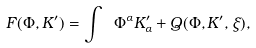<formula> <loc_0><loc_0><loc_500><loc_500>F ( \Phi , K ^ { \prime } ) = \int \ \Phi ^ { \alpha } K _ { \alpha } ^ { \prime } + Q ( \Phi , K ^ { \prime } , \xi ) ,</formula> 